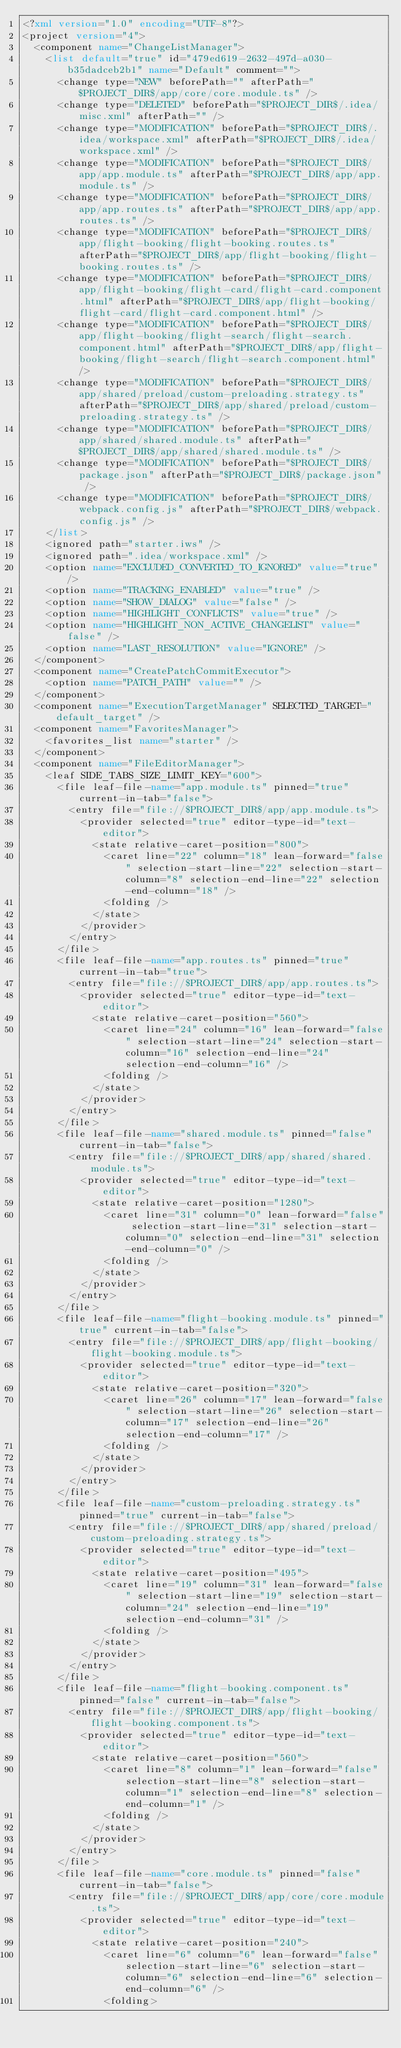Convert code to text. <code><loc_0><loc_0><loc_500><loc_500><_XML_><?xml version="1.0" encoding="UTF-8"?>
<project version="4">
  <component name="ChangeListManager">
    <list default="true" id="479ed619-2632-497d-a030-b35dadceb2b1" name="Default" comment="">
      <change type="NEW" beforePath="" afterPath="$PROJECT_DIR$/app/core/core.module.ts" />
      <change type="DELETED" beforePath="$PROJECT_DIR$/.idea/misc.xml" afterPath="" />
      <change type="MODIFICATION" beforePath="$PROJECT_DIR$/.idea/workspace.xml" afterPath="$PROJECT_DIR$/.idea/workspace.xml" />
      <change type="MODIFICATION" beforePath="$PROJECT_DIR$/app/app.module.ts" afterPath="$PROJECT_DIR$/app/app.module.ts" />
      <change type="MODIFICATION" beforePath="$PROJECT_DIR$/app/app.routes.ts" afterPath="$PROJECT_DIR$/app/app.routes.ts" />
      <change type="MODIFICATION" beforePath="$PROJECT_DIR$/app/flight-booking/flight-booking.routes.ts" afterPath="$PROJECT_DIR$/app/flight-booking/flight-booking.routes.ts" />
      <change type="MODIFICATION" beforePath="$PROJECT_DIR$/app/flight-booking/flight-card/flight-card.component.html" afterPath="$PROJECT_DIR$/app/flight-booking/flight-card/flight-card.component.html" />
      <change type="MODIFICATION" beforePath="$PROJECT_DIR$/app/flight-booking/flight-search/flight-search.component.html" afterPath="$PROJECT_DIR$/app/flight-booking/flight-search/flight-search.component.html" />
      <change type="MODIFICATION" beforePath="$PROJECT_DIR$/app/shared/preload/custom-preloading.strategy.ts" afterPath="$PROJECT_DIR$/app/shared/preload/custom-preloading.strategy.ts" />
      <change type="MODIFICATION" beforePath="$PROJECT_DIR$/app/shared/shared.module.ts" afterPath="$PROJECT_DIR$/app/shared/shared.module.ts" />
      <change type="MODIFICATION" beforePath="$PROJECT_DIR$/package.json" afterPath="$PROJECT_DIR$/package.json" />
      <change type="MODIFICATION" beforePath="$PROJECT_DIR$/webpack.config.js" afterPath="$PROJECT_DIR$/webpack.config.js" />
    </list>
    <ignored path="starter.iws" />
    <ignored path=".idea/workspace.xml" />
    <option name="EXCLUDED_CONVERTED_TO_IGNORED" value="true" />
    <option name="TRACKING_ENABLED" value="true" />
    <option name="SHOW_DIALOG" value="false" />
    <option name="HIGHLIGHT_CONFLICTS" value="true" />
    <option name="HIGHLIGHT_NON_ACTIVE_CHANGELIST" value="false" />
    <option name="LAST_RESOLUTION" value="IGNORE" />
  </component>
  <component name="CreatePatchCommitExecutor">
    <option name="PATCH_PATH" value="" />
  </component>
  <component name="ExecutionTargetManager" SELECTED_TARGET="default_target" />
  <component name="FavoritesManager">
    <favorites_list name="starter" />
  </component>
  <component name="FileEditorManager">
    <leaf SIDE_TABS_SIZE_LIMIT_KEY="600">
      <file leaf-file-name="app.module.ts" pinned="true" current-in-tab="false">
        <entry file="file://$PROJECT_DIR$/app/app.module.ts">
          <provider selected="true" editor-type-id="text-editor">
            <state relative-caret-position="800">
              <caret line="22" column="18" lean-forward="false" selection-start-line="22" selection-start-column="8" selection-end-line="22" selection-end-column="18" />
              <folding />
            </state>
          </provider>
        </entry>
      </file>
      <file leaf-file-name="app.routes.ts" pinned="true" current-in-tab="true">
        <entry file="file://$PROJECT_DIR$/app/app.routes.ts">
          <provider selected="true" editor-type-id="text-editor">
            <state relative-caret-position="560">
              <caret line="24" column="16" lean-forward="false" selection-start-line="24" selection-start-column="16" selection-end-line="24" selection-end-column="16" />
              <folding />
            </state>
          </provider>
        </entry>
      </file>
      <file leaf-file-name="shared.module.ts" pinned="false" current-in-tab="false">
        <entry file="file://$PROJECT_DIR$/app/shared/shared.module.ts">
          <provider selected="true" editor-type-id="text-editor">
            <state relative-caret-position="1280">
              <caret line="31" column="0" lean-forward="false" selection-start-line="31" selection-start-column="0" selection-end-line="31" selection-end-column="0" />
              <folding />
            </state>
          </provider>
        </entry>
      </file>
      <file leaf-file-name="flight-booking.module.ts" pinned="true" current-in-tab="false">
        <entry file="file://$PROJECT_DIR$/app/flight-booking/flight-booking.module.ts">
          <provider selected="true" editor-type-id="text-editor">
            <state relative-caret-position="320">
              <caret line="26" column="17" lean-forward="false" selection-start-line="26" selection-start-column="17" selection-end-line="26" selection-end-column="17" />
              <folding />
            </state>
          </provider>
        </entry>
      </file>
      <file leaf-file-name="custom-preloading.strategy.ts" pinned="true" current-in-tab="false">
        <entry file="file://$PROJECT_DIR$/app/shared/preload/custom-preloading.strategy.ts">
          <provider selected="true" editor-type-id="text-editor">
            <state relative-caret-position="495">
              <caret line="19" column="31" lean-forward="false" selection-start-line="19" selection-start-column="24" selection-end-line="19" selection-end-column="31" />
              <folding />
            </state>
          </provider>
        </entry>
      </file>
      <file leaf-file-name="flight-booking.component.ts" pinned="false" current-in-tab="false">
        <entry file="file://$PROJECT_DIR$/app/flight-booking/flight-booking.component.ts">
          <provider selected="true" editor-type-id="text-editor">
            <state relative-caret-position="560">
              <caret line="8" column="1" lean-forward="false" selection-start-line="8" selection-start-column="1" selection-end-line="8" selection-end-column="1" />
              <folding />
            </state>
          </provider>
        </entry>
      </file>
      <file leaf-file-name="core.module.ts" pinned="false" current-in-tab="false">
        <entry file="file://$PROJECT_DIR$/app/core/core.module.ts">
          <provider selected="true" editor-type-id="text-editor">
            <state relative-caret-position="240">
              <caret line="6" column="6" lean-forward="false" selection-start-line="6" selection-start-column="6" selection-end-line="6" selection-end-column="6" />
              <folding></code> 